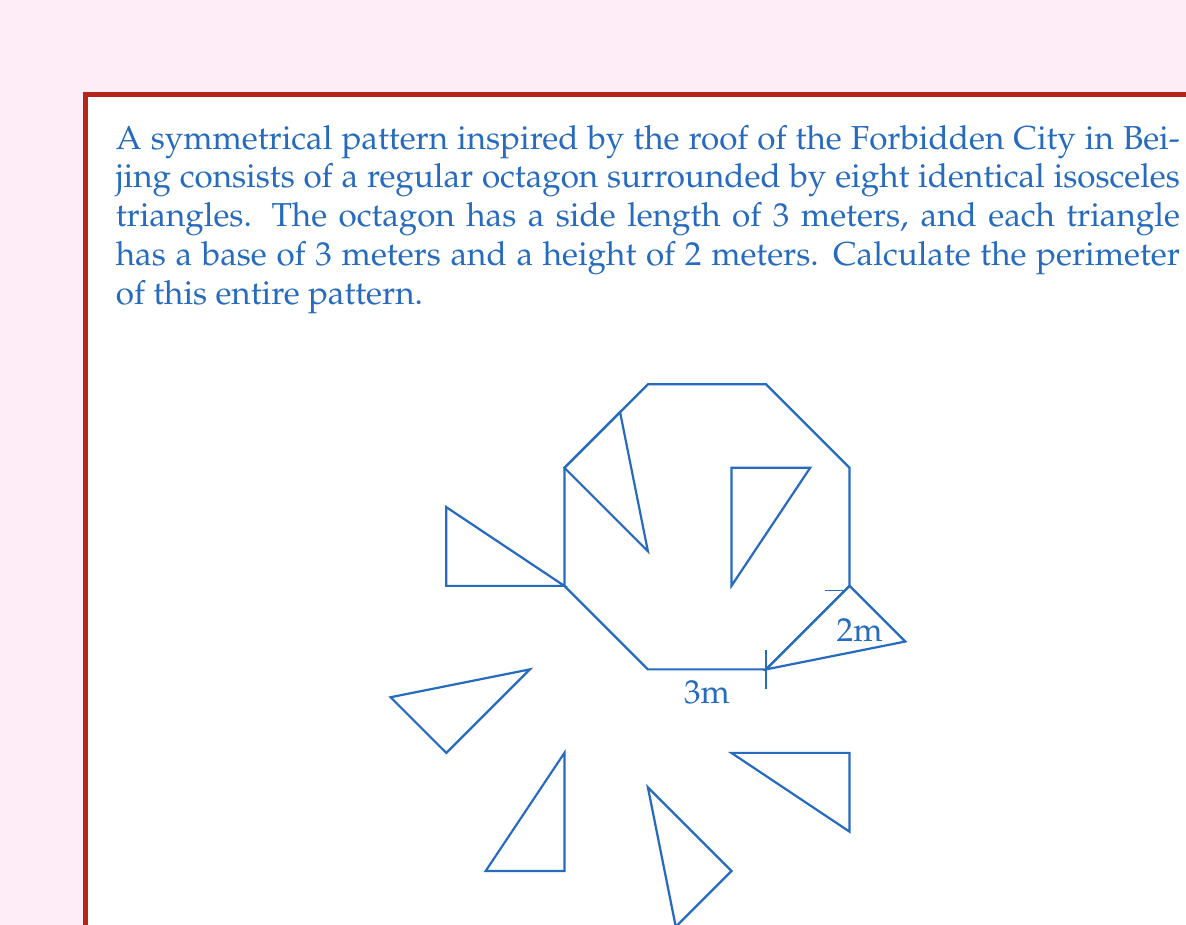What is the answer to this math problem? Let's approach this step-by-step:

1) First, we need to calculate the side length of each isosceles triangle:
   Using the Pythagorean theorem: $s^2 = (\frac{3}{2})^2 + 2^2$
   $s^2 = \frac{9}{4} + 4 = \frac{25}{4}$
   $s = \frac{5}{2} = 2.5$ meters

2) The perimeter of the pattern consists of:
   - The outer sides of the 8 isosceles triangles
   - None of the octagon sides (as they are all covered by triangle bases)

3) Each isosceles triangle contributes 2 sides to the perimeter:
   Number of sides contributing to perimeter = $8 \times 2 = 16$

4) Length of each contributing side = 2.5 meters

5) Total perimeter = $16 \times 2.5 = 40$ meters

Therefore, the perimeter of the entire pattern is 40 meters.
Answer: $40$ meters 